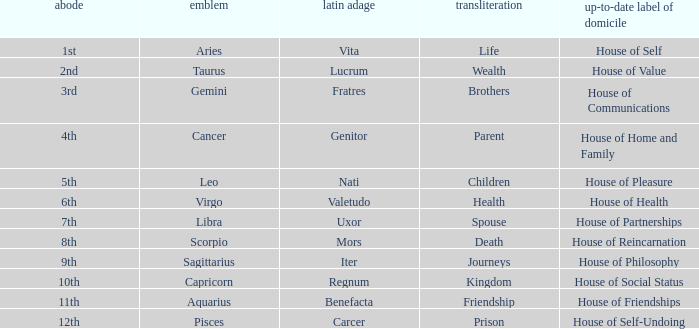Which modern house title translates to prison? House of Self-Undoing. 